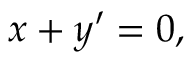Convert formula to latex. <formula><loc_0><loc_0><loc_500><loc_500>x + y \prime = 0 ,</formula> 